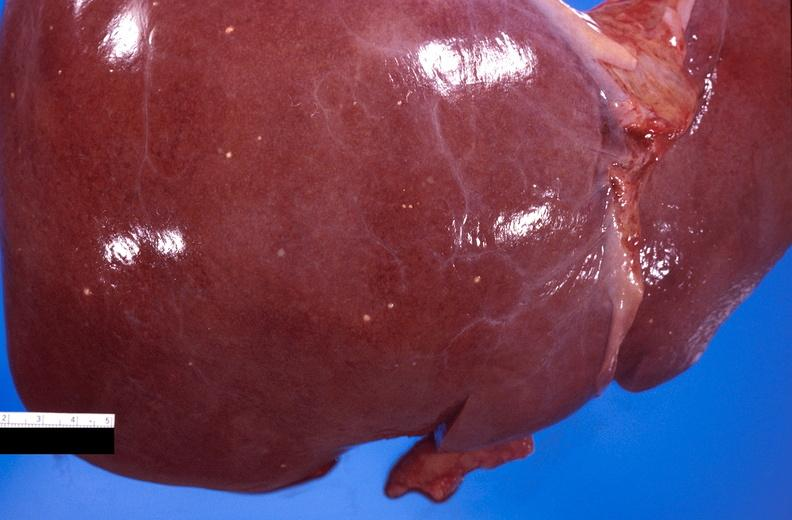does atherosclerosis show liver, fungal abscesses, candida?
Answer the question using a single word or phrase. No 